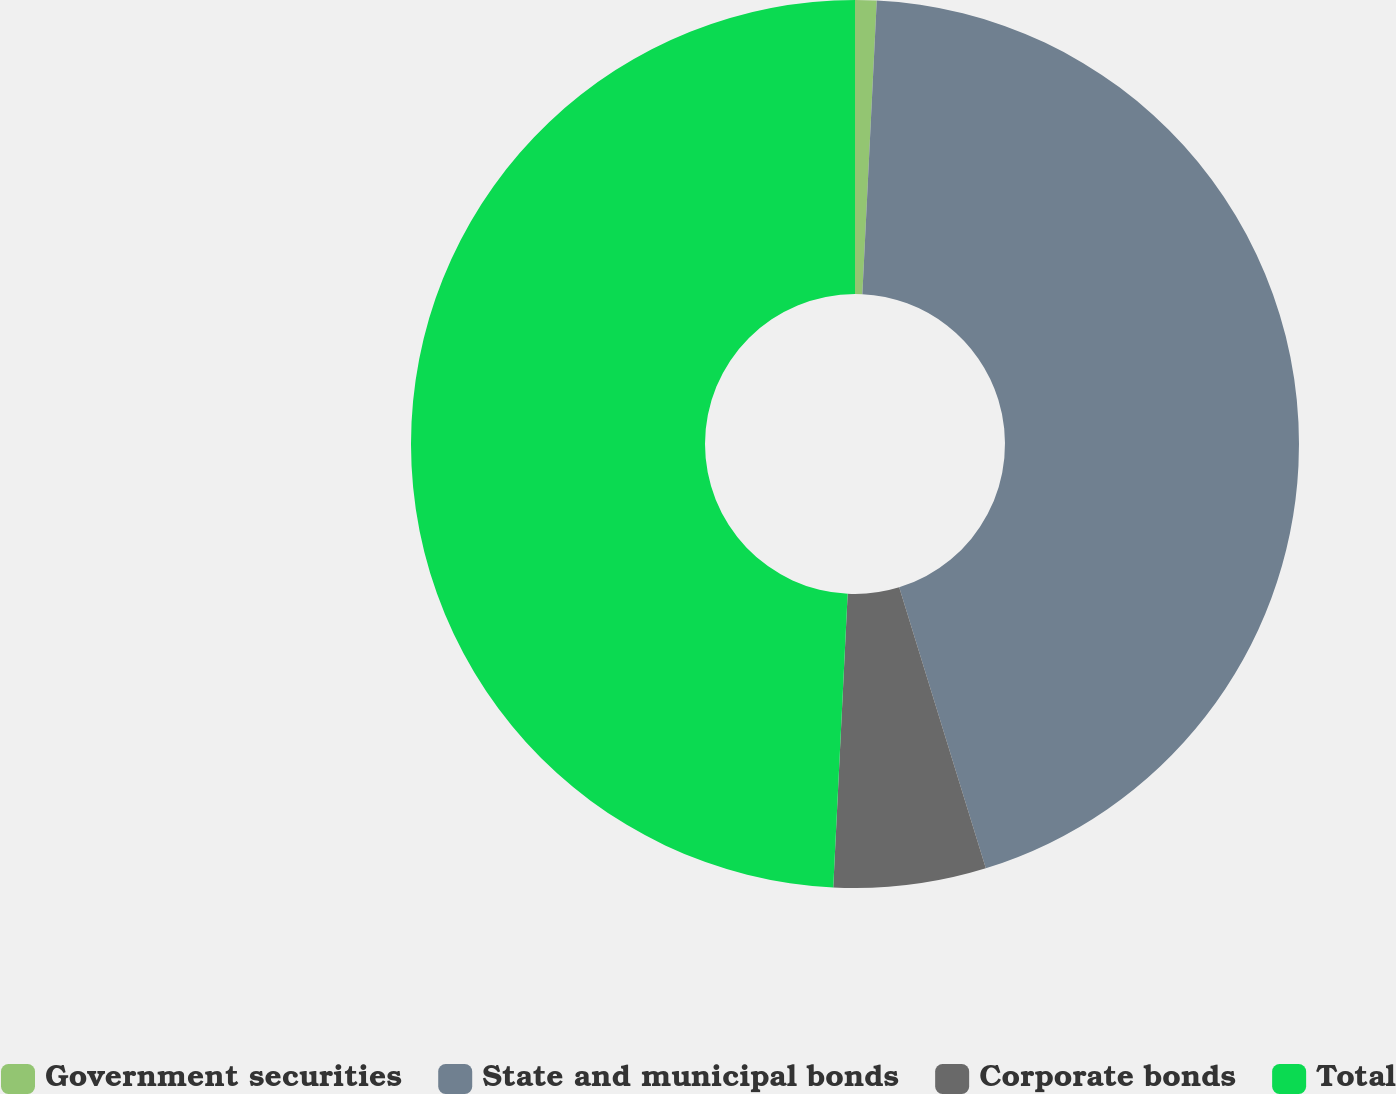Convert chart. <chart><loc_0><loc_0><loc_500><loc_500><pie_chart><fcel>Government securities<fcel>State and municipal bonds<fcel>Corporate bonds<fcel>Total<nl><fcel>0.78%<fcel>44.46%<fcel>5.54%<fcel>49.22%<nl></chart> 